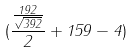Convert formula to latex. <formula><loc_0><loc_0><loc_500><loc_500>( \frac { \frac { 1 9 2 } { \sqrt { 3 9 2 } } } { 2 } + 1 5 9 - 4 )</formula> 